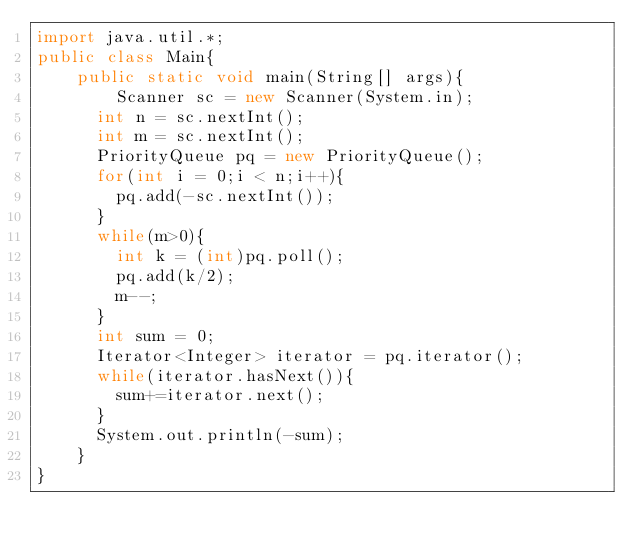Convert code to text. <code><loc_0><loc_0><loc_500><loc_500><_Java_>import java.util.*;
public class Main{
	public static void main(String[] args){
    	Scanner sc = new Scanner(System.in);
      int n = sc.nextInt();
      int m = sc.nextInt();
      PriorityQueue pq = new PriorityQueue();
      for(int i = 0;i < n;i++){
        pq.add(-sc.nextInt());
      }
      while(m>0){
      	int k = (int)pq.poll();
        pq.add(k/2);
        m--;
      }
      int sum = 0;
      Iterator<Integer> iterator = pq.iterator();
      while(iterator.hasNext()){
      	sum+=iterator.next();
      }
      System.out.println(-sum);
    }
}</code> 